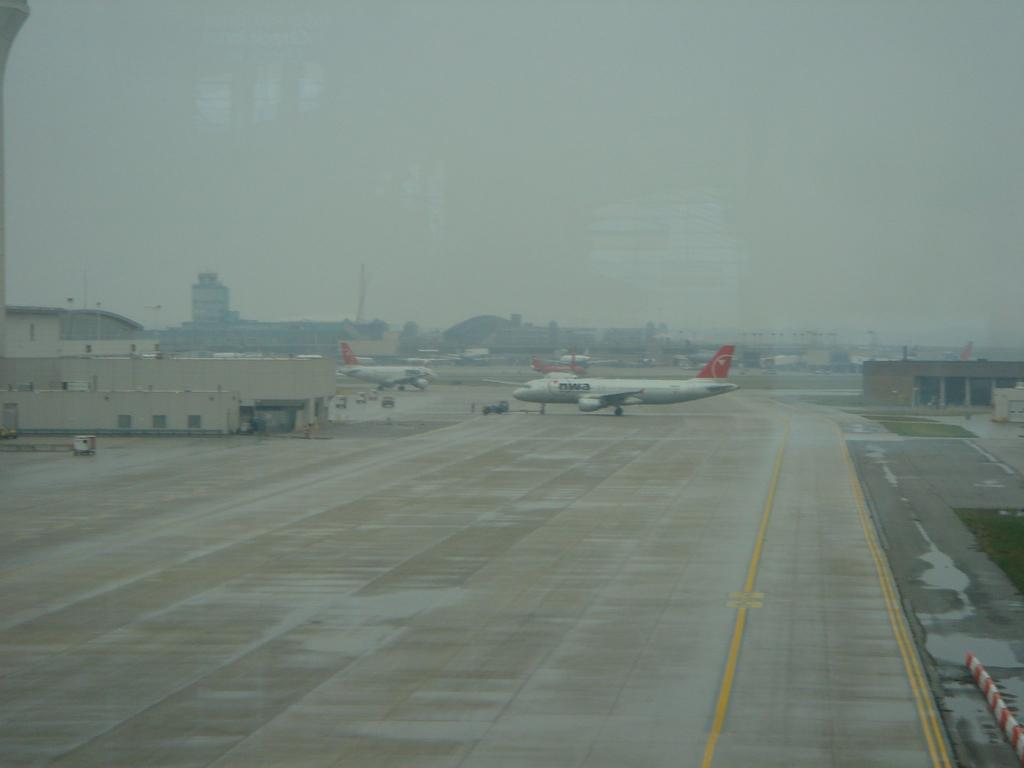What type of transportation is depicted in the image? There are aircraft and vehicles in the image. What type of structures can be seen in the image? There are sheds and buildings in the image. What is visible in the background of the image? The sky is visible in the background of the image. What caption is written on the line in the image? There is no caption or line present in the image. How does the image change when viewed from a different angle? The image does not change when viewed from a different angle, as it is a static representation. 